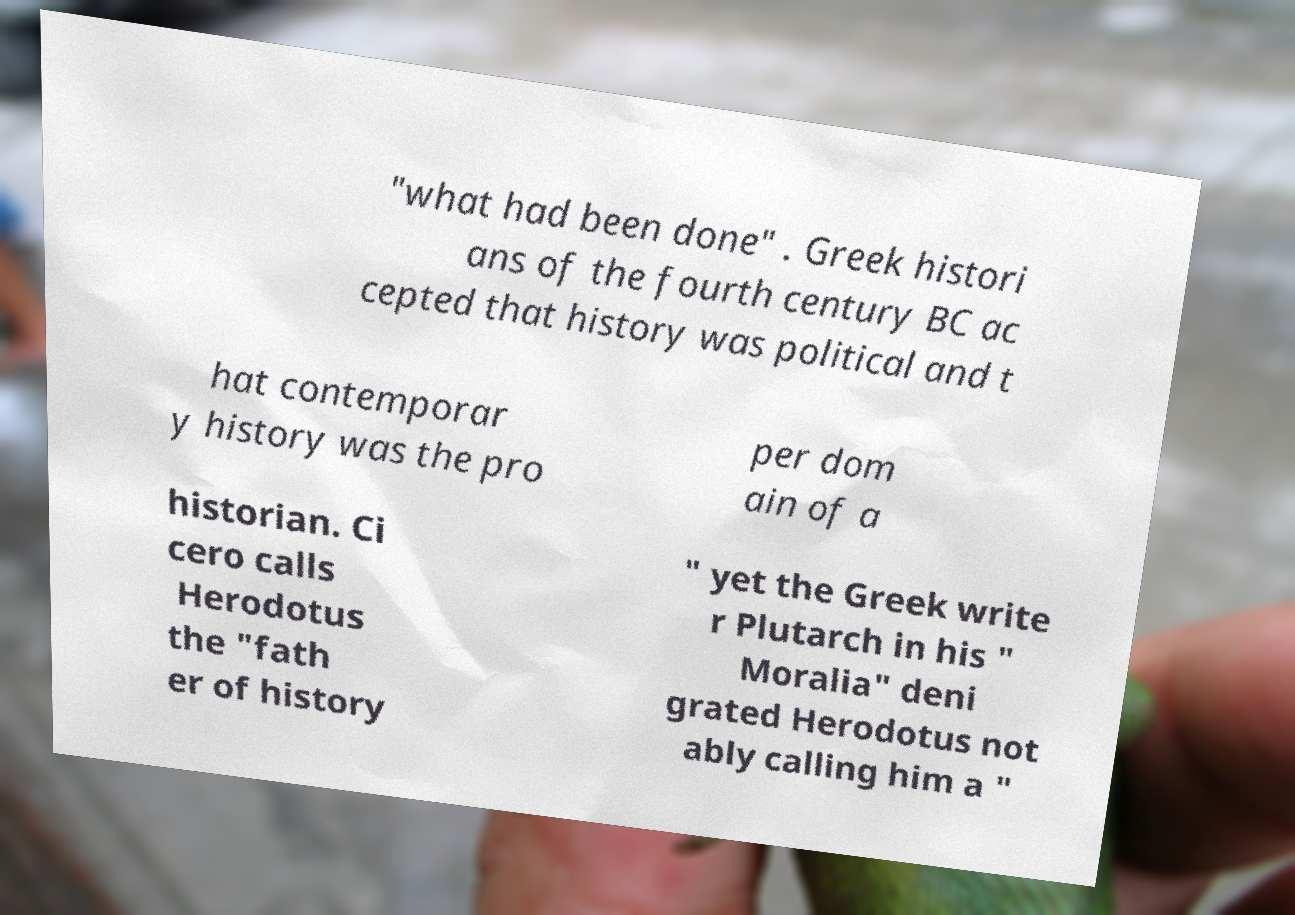For documentation purposes, I need the text within this image transcribed. Could you provide that? "what had been done" . Greek histori ans of the fourth century BC ac cepted that history was political and t hat contemporar y history was the pro per dom ain of a historian. Ci cero calls Herodotus the "fath er of history " yet the Greek write r Plutarch in his " Moralia" deni grated Herodotus not ably calling him a " 